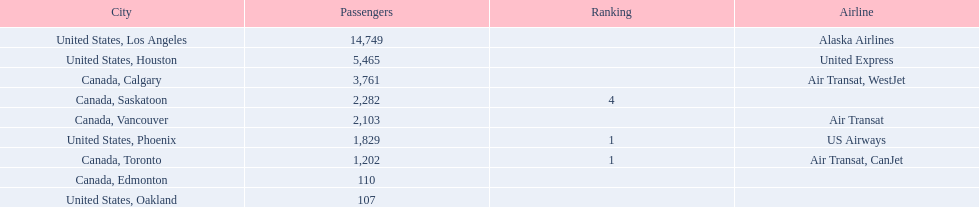What cities do the planes fly to? United States, Los Angeles, United States, Houston, Canada, Calgary, Canada, Saskatoon, Canada, Vancouver, United States, Phoenix, Canada, Toronto, Canada, Edmonton, United States, Oakland. How many people are flying to phoenix, arizona? 1,829. 